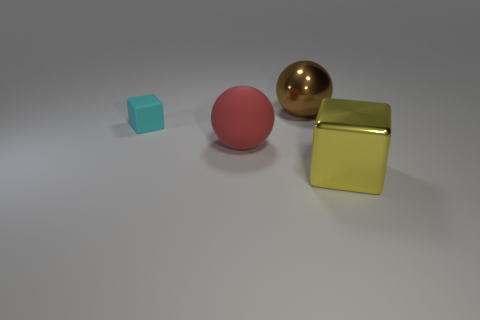Could you describe the atmosphere or mood of this image? The image exudes a calm and minimalist atmosphere. The soft lighting, the neutral background, and the simple geometric shapes contribute to a modern and tranquil setting. The smooth surfaces and subtle reflections offer a sense of cleanliness and order.  What could be the purpose of such an arrangement in this image? This arrangement might serve as a visual study of geometry and textures in a controlled setting, often used for artistic or educational purposes. Such a setup could be used to demonstrate principles of light, shadow, and color within a scene, or to provide a visually soothing or engaging composition. 